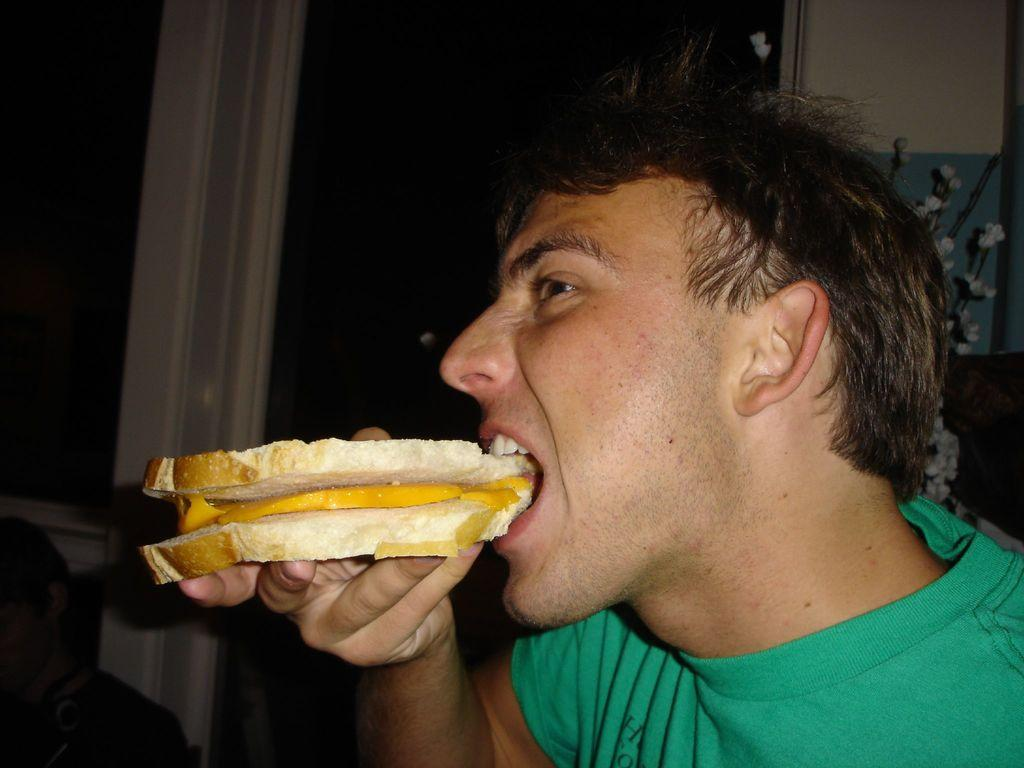What is the person in the image doing? The person in the image is eating bread. Can you describe the background of the image? There are windows visible in the background of the image. What type of slave is depicted in the image? There is no slave depicted in the image; it features a person eating bread. What kind of substance is being used to make the pie in the image? There is no pie present in the image; it features a person eating bread and windows in the background. 